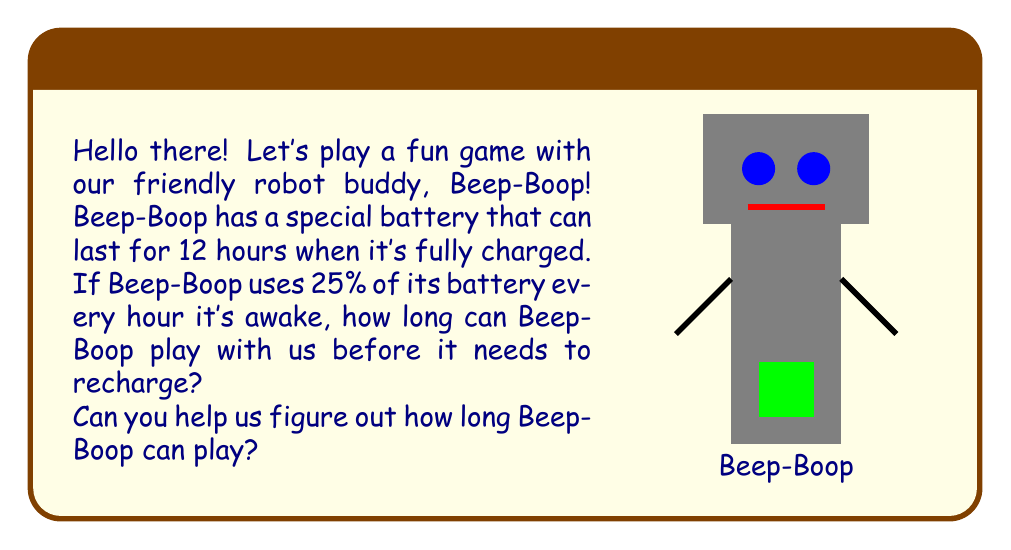Solve this math problem. Let's solve this step-by-step:

1) First, we need to understand what the question is asking:
   - Beep-Boop's battery lasts 12 hours when fully charged
   - It uses 25% (or 1/4) of its battery every hour

2) We can set up an equation to represent this:
   Let $x$ be the number of hours Beep-Boop can operate
   $$\frac{1}{4}x = 12$$

3) This equation means that 1/4 of the total operating time equals the full battery life

4) To solve for $x$, we multiply both sides by 4:
   $$4 \cdot \frac{1}{4}x = 4 \cdot 12$$
   $$x = 48$$

5) Therefore, Beep-Boop can operate for 48 hours before needing to recharge

Let's check:
- In 1 hour, Beep-Boop uses 25% of its battery
- In 48 hours, it will use: $48 \cdot 25\% = 1200\% = 12$ full batteries

This matches our initial information that one full battery lasts 12 hours.
Answer: 48 hours 